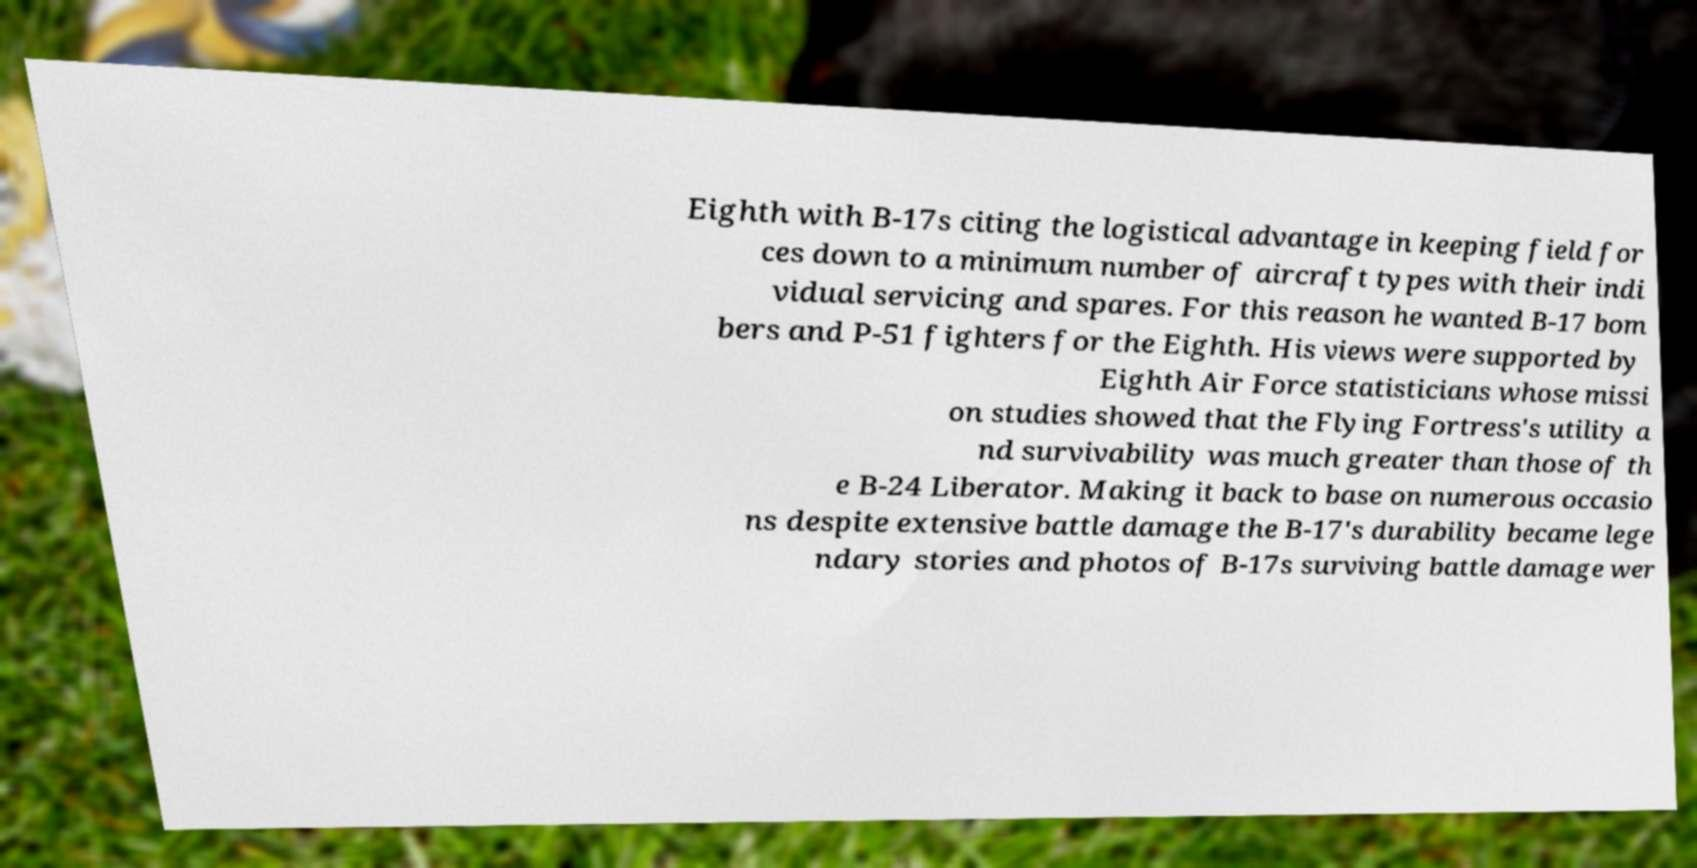Please identify and transcribe the text found in this image. Eighth with B-17s citing the logistical advantage in keeping field for ces down to a minimum number of aircraft types with their indi vidual servicing and spares. For this reason he wanted B-17 bom bers and P-51 fighters for the Eighth. His views were supported by Eighth Air Force statisticians whose missi on studies showed that the Flying Fortress's utility a nd survivability was much greater than those of th e B-24 Liberator. Making it back to base on numerous occasio ns despite extensive battle damage the B-17's durability became lege ndary stories and photos of B-17s surviving battle damage wer 